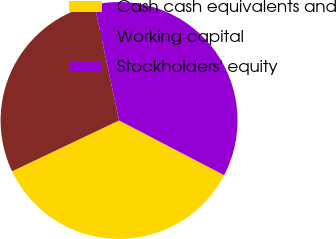Convert chart. <chart><loc_0><loc_0><loc_500><loc_500><pie_chart><fcel>Cash cash equivalents and<fcel>Working capital<fcel>Stockholders' equity<nl><fcel>35.3%<fcel>28.73%<fcel>35.97%<nl></chart> 